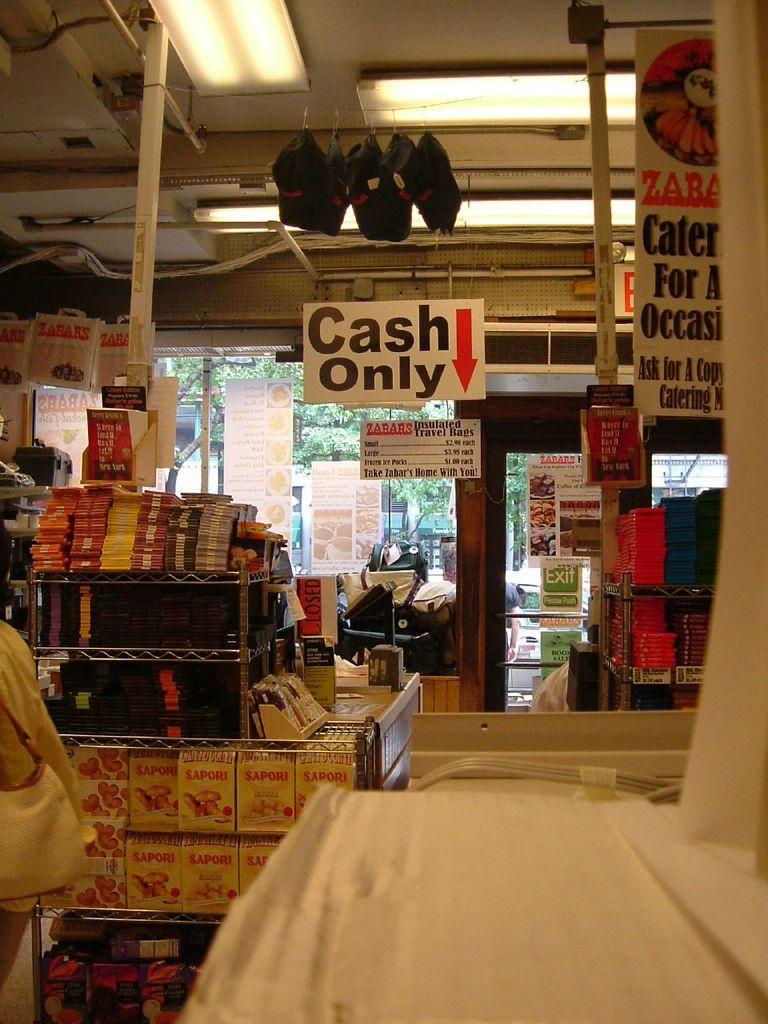Describe this image in one or two sentences. This picture is clicked inside. In the foreground we can see the boxes and books and some other items. At the top we can see the roof, lights, metal rods and the caps hanging on the roof and we can see the banners on which we can see the text and some pictures and we can see the cabinets containing many number of items. In the background we can see the trees and many other objects. 